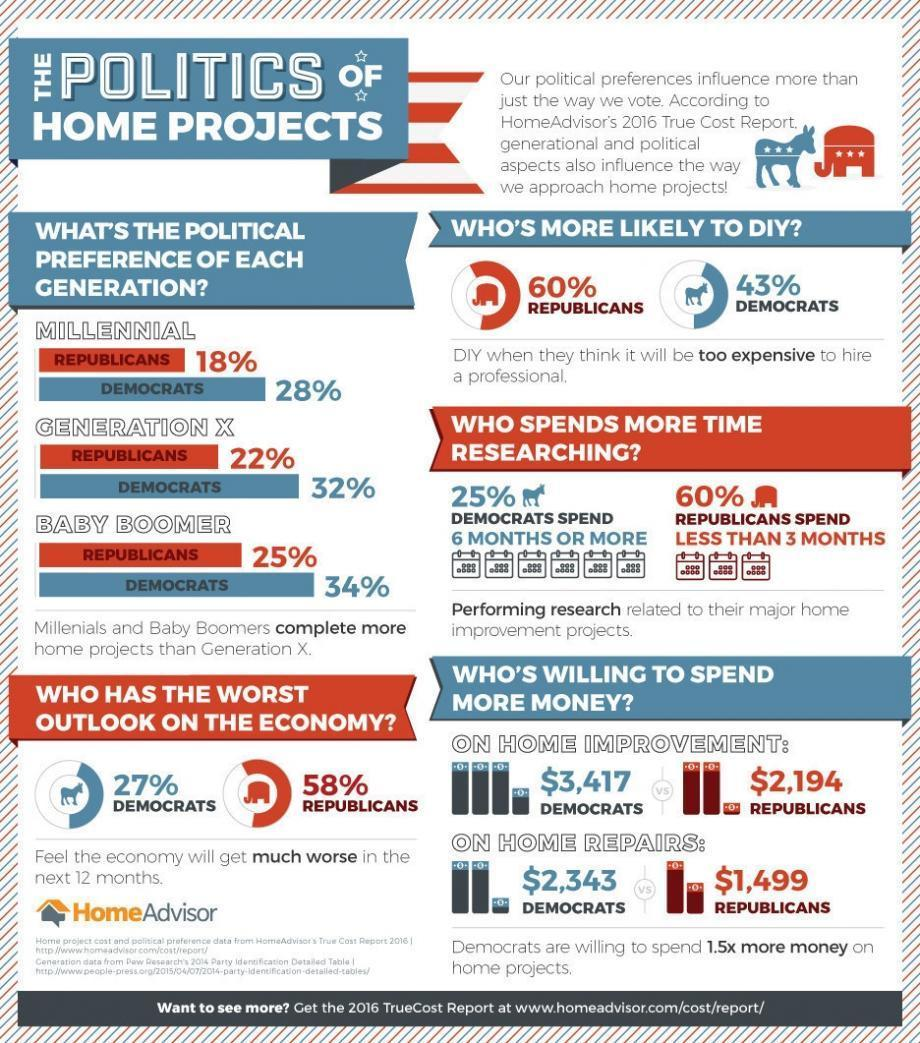which political party most of the generation x prefer among democrats and republican?
Answer the question with a short phrase. democrats what is the total amount republicans willing to pay on home repairs and home improvement taken together in dollars? 3693 who is willing to spend more money on home improvement? democrats which political party most of the millennials prefer among democrats and republican? democrats who is willing to spend more money on home repairs? democrats which political party most of the baby boomers prefer among democrats and republican? democrats what is the total amount democrats willing to pay on home repairs and home improvement taken together in dollars? 5760 